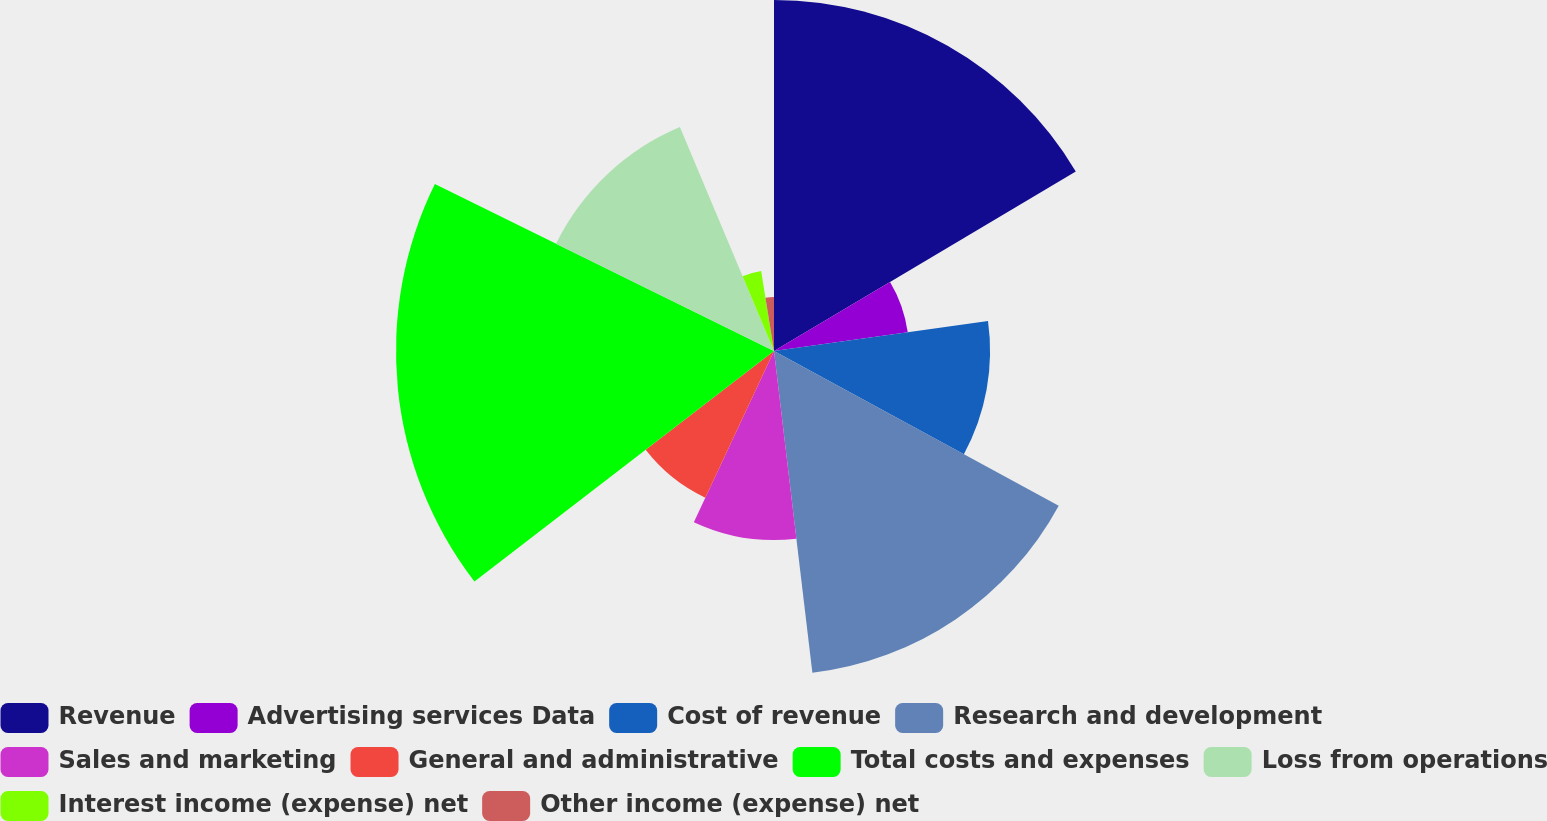Convert chart to OTSL. <chart><loc_0><loc_0><loc_500><loc_500><pie_chart><fcel>Revenue<fcel>Advertising services Data<fcel>Cost of revenue<fcel>Research and development<fcel>Sales and marketing<fcel>General and administrative<fcel>Total costs and expenses<fcel>Loss from operations<fcel>Interest income (expense) net<fcel>Other income (expense) net<nl><fcel>16.46%<fcel>6.33%<fcel>10.13%<fcel>15.19%<fcel>8.86%<fcel>7.59%<fcel>17.72%<fcel>11.39%<fcel>3.8%<fcel>2.53%<nl></chart> 